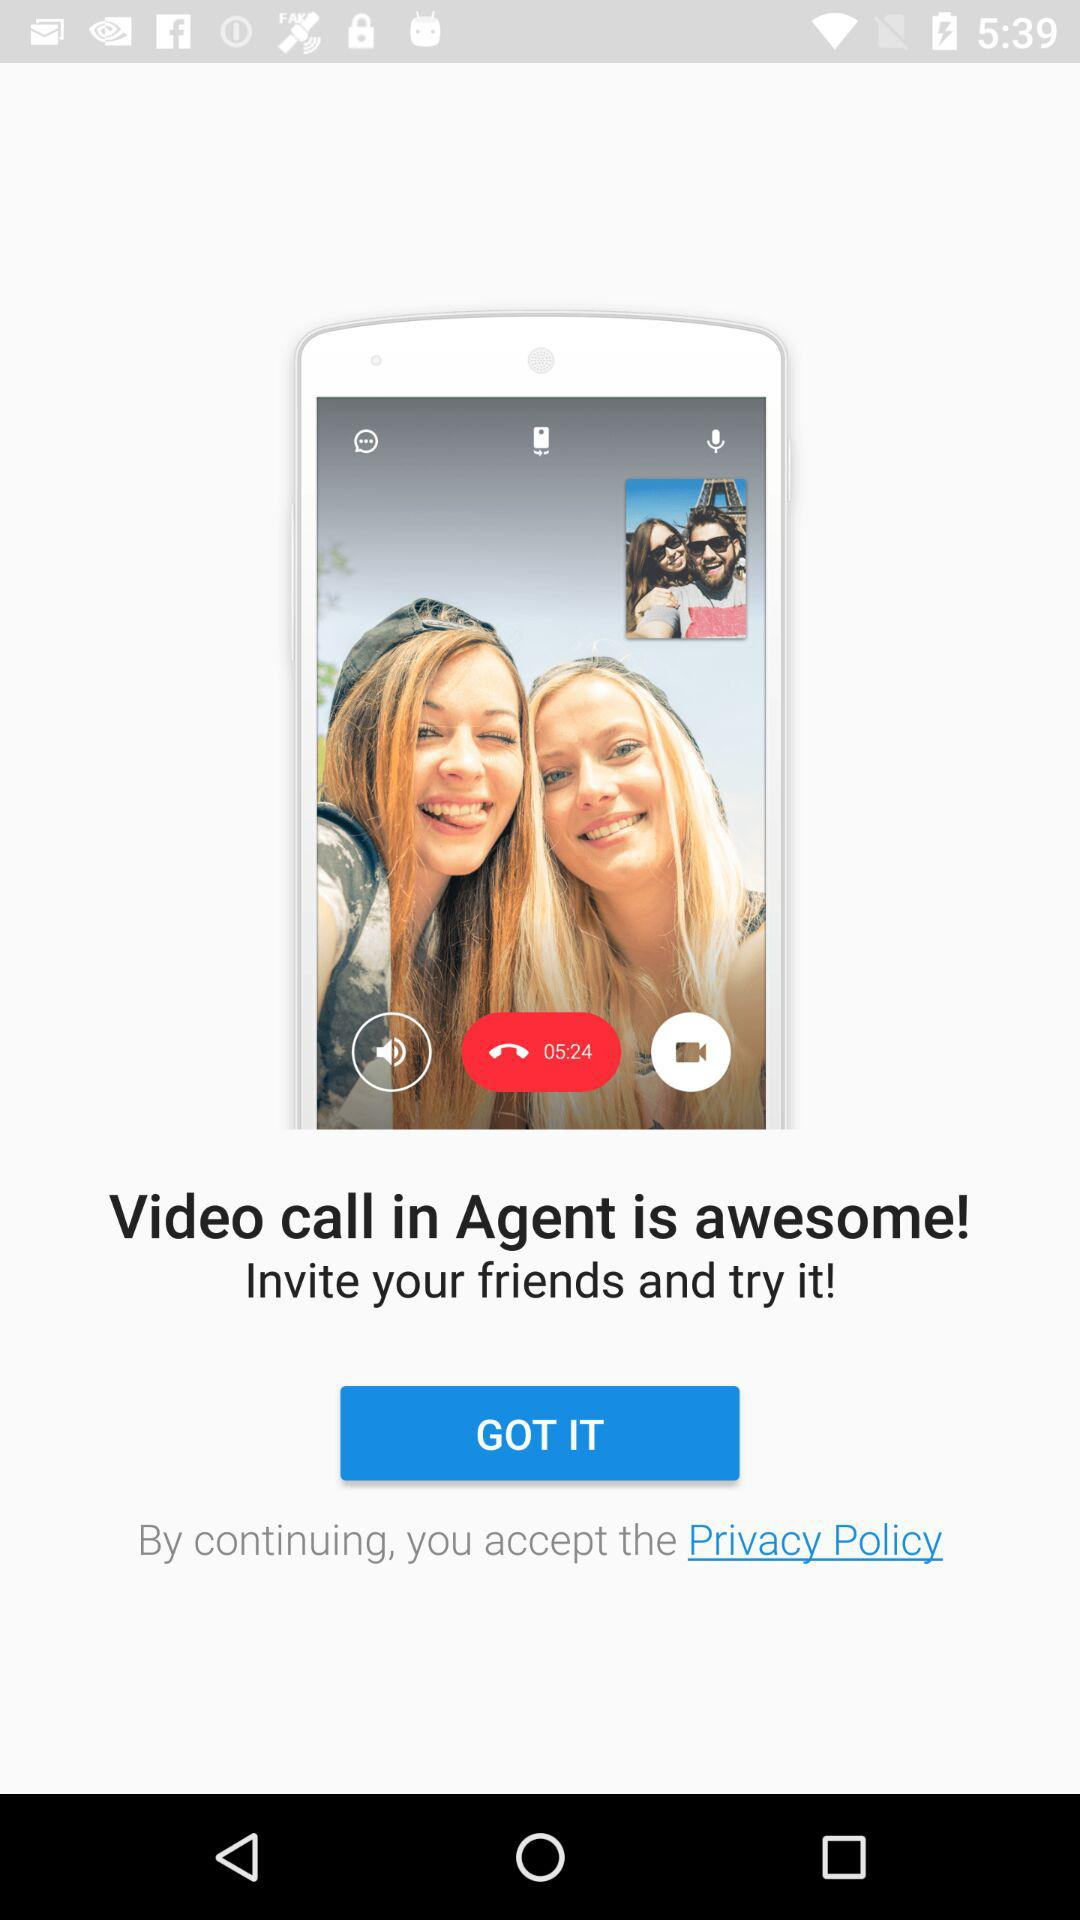What is the name of the application? The name of the application is "Agent". 